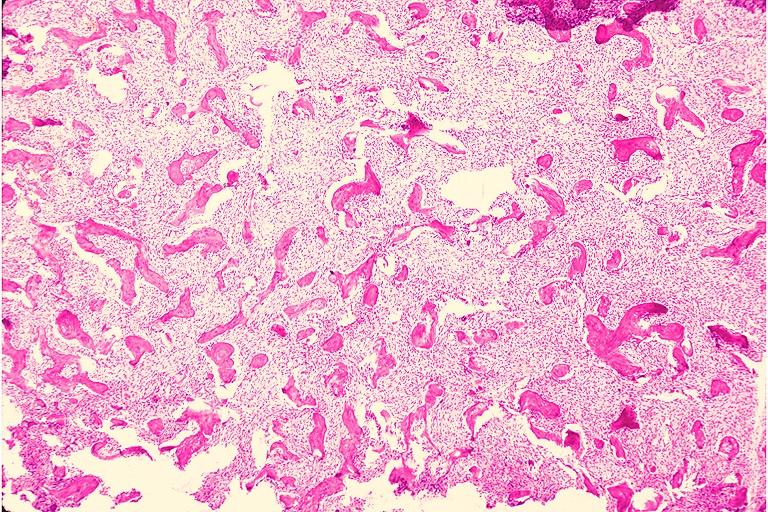what does this image show?
Answer the question using a single word or phrase. Fibrous dysplasia 